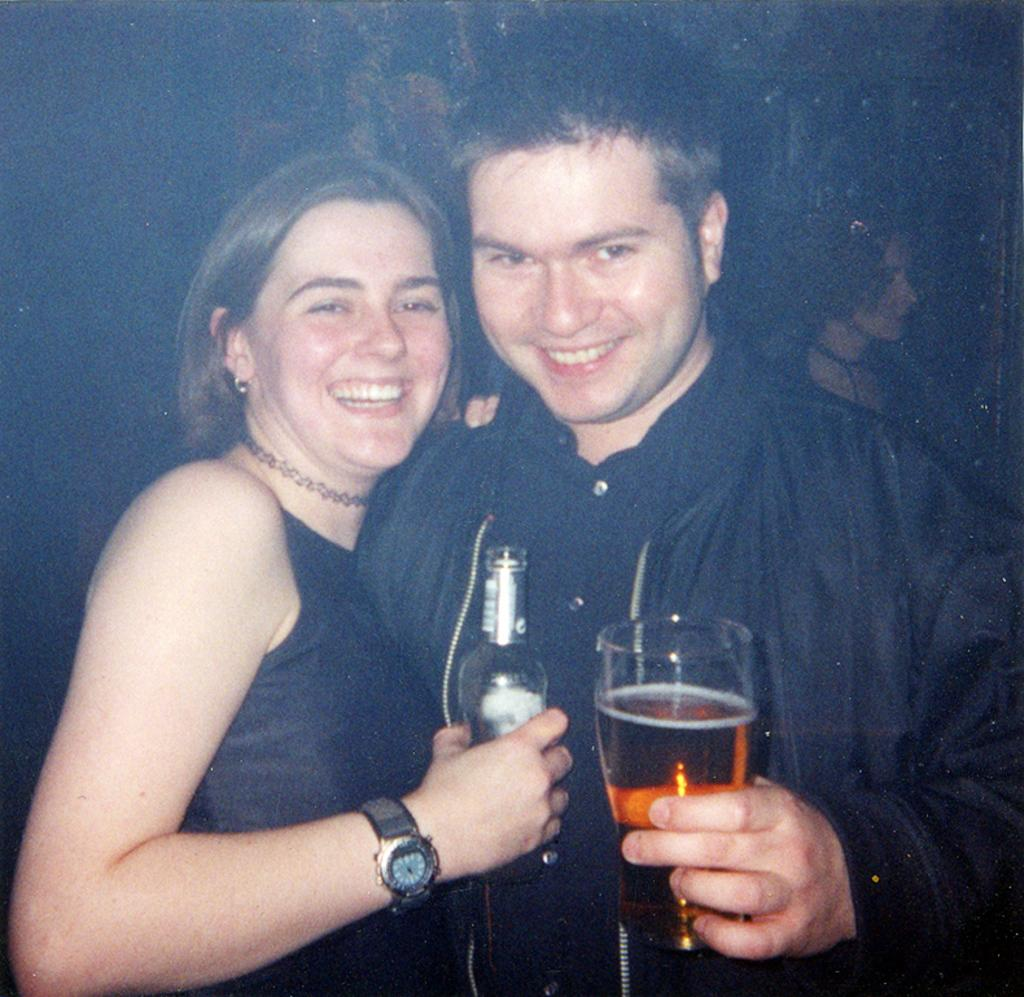How many people are in the image? There are two people in the image. What are the people doing in the image? The people are standing and smiling. What are the people holding in their hands? The people are holding a wine glass in their hand. What type of rhythm can be heard in the image? There is no sound or rhythm present in the image, as it is a still photograph. 